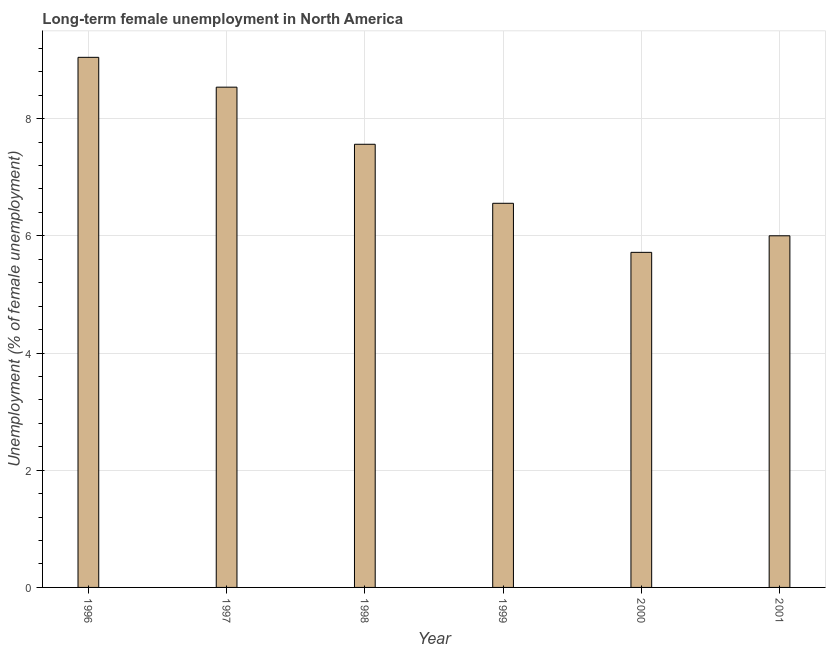Does the graph contain any zero values?
Give a very brief answer. No. Does the graph contain grids?
Offer a very short reply. Yes. What is the title of the graph?
Keep it short and to the point. Long-term female unemployment in North America. What is the label or title of the Y-axis?
Your answer should be very brief. Unemployment (% of female unemployment). What is the long-term female unemployment in 1996?
Ensure brevity in your answer.  9.05. Across all years, what is the maximum long-term female unemployment?
Provide a succinct answer. 9.05. Across all years, what is the minimum long-term female unemployment?
Give a very brief answer. 5.72. What is the sum of the long-term female unemployment?
Your answer should be compact. 43.42. What is the difference between the long-term female unemployment in 1996 and 1997?
Your answer should be compact. 0.51. What is the average long-term female unemployment per year?
Give a very brief answer. 7.24. What is the median long-term female unemployment?
Your response must be concise. 7.06. In how many years, is the long-term female unemployment greater than 8.4 %?
Provide a succinct answer. 2. What is the ratio of the long-term female unemployment in 1996 to that in 2000?
Make the answer very short. 1.58. Is the long-term female unemployment in 1997 less than that in 1998?
Your response must be concise. No. What is the difference between the highest and the second highest long-term female unemployment?
Make the answer very short. 0.51. Is the sum of the long-term female unemployment in 1999 and 2000 greater than the maximum long-term female unemployment across all years?
Provide a short and direct response. Yes. What is the difference between the highest and the lowest long-term female unemployment?
Offer a terse response. 3.33. In how many years, is the long-term female unemployment greater than the average long-term female unemployment taken over all years?
Keep it short and to the point. 3. Are all the bars in the graph horizontal?
Offer a very short reply. No. What is the difference between two consecutive major ticks on the Y-axis?
Keep it short and to the point. 2. What is the Unemployment (% of female unemployment) of 1996?
Give a very brief answer. 9.05. What is the Unemployment (% of female unemployment) of 1997?
Keep it short and to the point. 8.54. What is the Unemployment (% of female unemployment) in 1998?
Provide a succinct answer. 7.56. What is the Unemployment (% of female unemployment) in 1999?
Give a very brief answer. 6.56. What is the Unemployment (% of female unemployment) of 2000?
Provide a short and direct response. 5.72. What is the Unemployment (% of female unemployment) in 2001?
Your answer should be very brief. 6. What is the difference between the Unemployment (% of female unemployment) in 1996 and 1997?
Your answer should be very brief. 0.51. What is the difference between the Unemployment (% of female unemployment) in 1996 and 1998?
Your answer should be compact. 1.48. What is the difference between the Unemployment (% of female unemployment) in 1996 and 1999?
Provide a succinct answer. 2.49. What is the difference between the Unemployment (% of female unemployment) in 1996 and 2000?
Give a very brief answer. 3.33. What is the difference between the Unemployment (% of female unemployment) in 1996 and 2001?
Keep it short and to the point. 3.05. What is the difference between the Unemployment (% of female unemployment) in 1997 and 1998?
Offer a very short reply. 0.97. What is the difference between the Unemployment (% of female unemployment) in 1997 and 1999?
Offer a terse response. 1.98. What is the difference between the Unemployment (% of female unemployment) in 1997 and 2000?
Provide a short and direct response. 2.82. What is the difference between the Unemployment (% of female unemployment) in 1997 and 2001?
Give a very brief answer. 2.54. What is the difference between the Unemployment (% of female unemployment) in 1998 and 1999?
Your answer should be compact. 1.01. What is the difference between the Unemployment (% of female unemployment) in 1998 and 2000?
Provide a short and direct response. 1.84. What is the difference between the Unemployment (% of female unemployment) in 1998 and 2001?
Your answer should be compact. 1.56. What is the difference between the Unemployment (% of female unemployment) in 1999 and 2000?
Keep it short and to the point. 0.84. What is the difference between the Unemployment (% of female unemployment) in 1999 and 2001?
Your response must be concise. 0.55. What is the difference between the Unemployment (% of female unemployment) in 2000 and 2001?
Ensure brevity in your answer.  -0.28. What is the ratio of the Unemployment (% of female unemployment) in 1996 to that in 1997?
Your answer should be very brief. 1.06. What is the ratio of the Unemployment (% of female unemployment) in 1996 to that in 1998?
Give a very brief answer. 1.2. What is the ratio of the Unemployment (% of female unemployment) in 1996 to that in 1999?
Keep it short and to the point. 1.38. What is the ratio of the Unemployment (% of female unemployment) in 1996 to that in 2000?
Offer a terse response. 1.58. What is the ratio of the Unemployment (% of female unemployment) in 1996 to that in 2001?
Your response must be concise. 1.51. What is the ratio of the Unemployment (% of female unemployment) in 1997 to that in 1998?
Give a very brief answer. 1.13. What is the ratio of the Unemployment (% of female unemployment) in 1997 to that in 1999?
Offer a terse response. 1.3. What is the ratio of the Unemployment (% of female unemployment) in 1997 to that in 2000?
Make the answer very short. 1.49. What is the ratio of the Unemployment (% of female unemployment) in 1997 to that in 2001?
Your answer should be compact. 1.42. What is the ratio of the Unemployment (% of female unemployment) in 1998 to that in 1999?
Give a very brief answer. 1.15. What is the ratio of the Unemployment (% of female unemployment) in 1998 to that in 2000?
Your answer should be compact. 1.32. What is the ratio of the Unemployment (% of female unemployment) in 1998 to that in 2001?
Offer a very short reply. 1.26. What is the ratio of the Unemployment (% of female unemployment) in 1999 to that in 2000?
Offer a very short reply. 1.15. What is the ratio of the Unemployment (% of female unemployment) in 1999 to that in 2001?
Your answer should be compact. 1.09. What is the ratio of the Unemployment (% of female unemployment) in 2000 to that in 2001?
Your answer should be very brief. 0.95. 